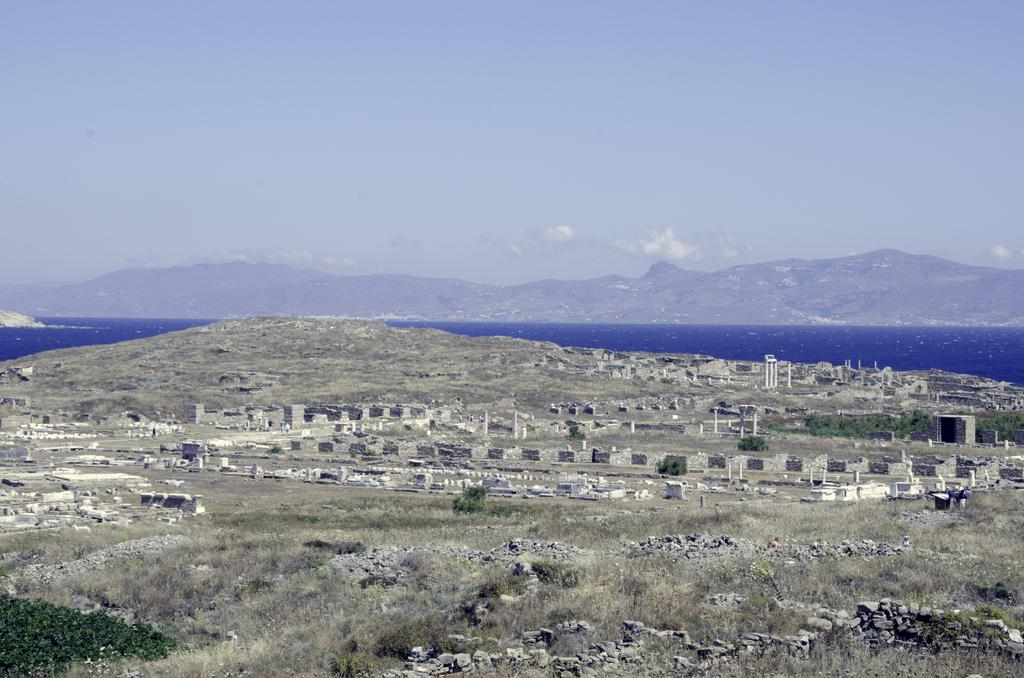What type of vegetation can be seen in the image? There is dry grass and trees visible in the image. What other objects can be seen in the image? There are stones, poles, and water visible in the image. What type of landscape is depicted in the image? The image appears to depict a construction site with mountains in the background. How many ghosts are visible in the image? There are no ghosts present in the image. What type of note is attached to the poles in the image? There are no notes attached to the poles in the image. 